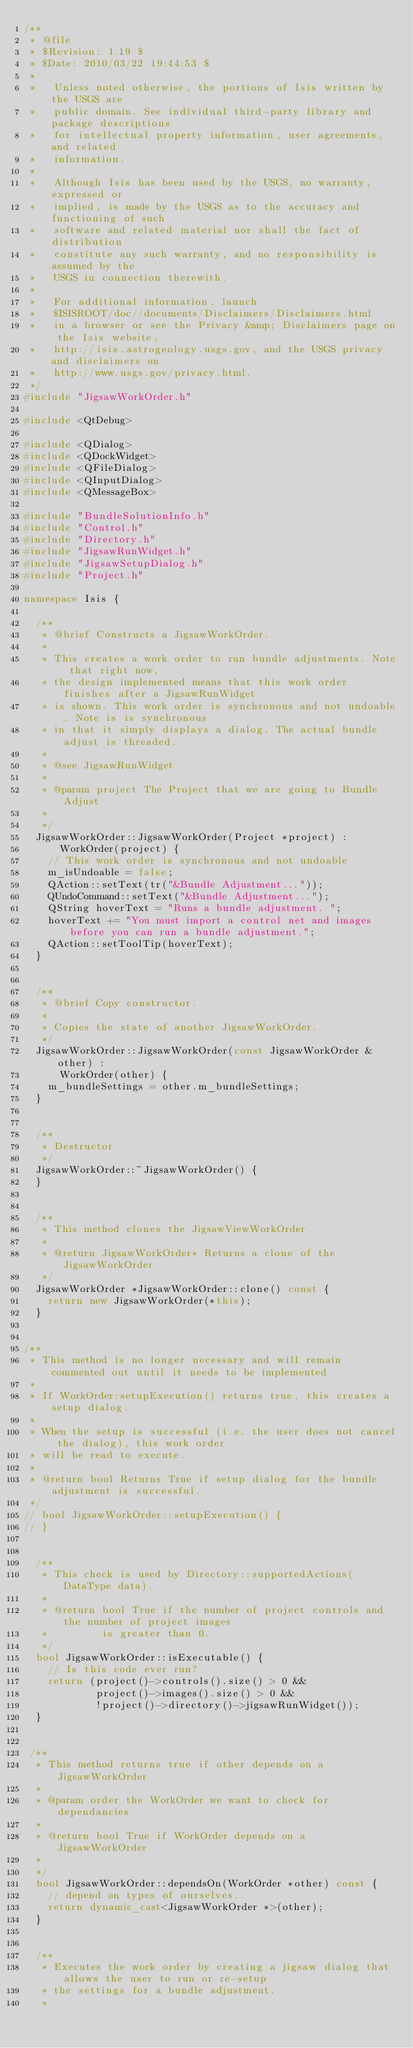<code> <loc_0><loc_0><loc_500><loc_500><_C++_>/**
 * @file
 * $Revision: 1.19 $
 * $Date: 2010/03/22 19:44:53 $
 *
 *   Unless noted otherwise, the portions of Isis written by the USGS are
 *   public domain. See individual third-party library and package descriptions
 *   for intellectual property information, user agreements, and related
 *   information.
 *
 *   Although Isis has been used by the USGS, no warranty, expressed or
 *   implied, is made by the USGS as to the accuracy and functioning of such
 *   software and related material nor shall the fact of distribution
 *   constitute any such warranty, and no responsibility is assumed by the
 *   USGS in connection therewith.
 *
 *   For additional information, launch
 *   $ISISROOT/doc//documents/Disclaimers/Disclaimers.html
 *   in a browser or see the Privacy &amp; Disclaimers page on the Isis website,
 *   http://isis.astrogeology.usgs.gov, and the USGS privacy and disclaimers on
 *   http://www.usgs.gov/privacy.html.
 */
#include "JigsawWorkOrder.h"

#include <QtDebug>

#include <QDialog>
#include <QDockWidget>
#include <QFileDialog>
#include <QInputDialog>
#include <QMessageBox>

#include "BundleSolutionInfo.h"
#include "Control.h"
#include "Directory.h"
#include "JigsawRunWidget.h"
#include "JigsawSetupDialog.h"
#include "Project.h"

namespace Isis {

  /**
   * @brief Constructs a JigsawWorkOrder.
   *
   * This creates a work order to run bundle adjustments. Note that right now,
   * the design implemented means that this work order finishes after a JigsawRunWidget
   * is shown. This work order is synchronous and not undoable. Note is is synchronous
   * in that it simply displays a dialog. The actual bundle adjust is threaded.
   *
   * @see JigsawRunWidget
   *
   * @param project The Project that we are going to Bundle Adjust
   *
   */
  JigsawWorkOrder::JigsawWorkOrder(Project *project) :
      WorkOrder(project) {
    // This work order is synchronous and not undoable
    m_isUndoable = false;
    QAction::setText(tr("&Bundle Adjustment..."));
    QUndoCommand::setText("&Bundle Adjustment...");
    QString hoverText = "Runs a bundle adjustment. ";
    hoverText += "You must import a control net and images before you can run a bundle adjustment.";
    QAction::setToolTip(hoverText);
  }


  /**
   * @brief Copy constructor.
   *
   * Copies the state of another JigsawWorkOrder.
   */
  JigsawWorkOrder::JigsawWorkOrder(const JigsawWorkOrder &other) :
      WorkOrder(other) {
    m_bundleSettings = other.m_bundleSettings;
  }


  /**
   * Destructor
   */
  JigsawWorkOrder::~JigsawWorkOrder() {
  }


  /**
   * This method clones the JigsawViewWorkOrder
   *
   * @return JigsawWorkOrder* Returns a clone of the JigsawWorkOrder
   */
  JigsawWorkOrder *JigsawWorkOrder::clone() const {
    return new JigsawWorkOrder(*this);
  }


/**
 * This method is no longer necessary and will remain commented out until it needs to be implemented 
 *  
 * If WorkOrder:setupExecution() returns true, this creates a setup dialog.   
 *    
 * When the setup is successful (i.e. the user does not cancel the dialog), this work order   
 * will be read to execute.   
 *    
 * @return bool Returns True if setup dialog for the bundle adjustment is successful.   
 */   
// bool JigsawWorkOrder::setupExecution() {    
// }


  /**
   * This check is used by Directory::supportedActions(DataType data).
   *
   * @return bool True if the number of project controls and the number of project images
   *         is greater than 0.
   */
  bool JigsawWorkOrder::isExecutable() {
    // Is this code ever run?
    return (project()->controls().size() > 0 && 
            project()->images().size() > 0 &&
            !project()->directory()->jigsawRunWidget());
  }


 /**
  * This method returns true if other depends on a JigsawWorkOrder
  *
  * @param order the WorkOrder we want to check for dependancies
  *
  * @return bool True if WorkOrder depends on a JigsawWorkOrder
  *
  */
  bool JigsawWorkOrder::dependsOn(WorkOrder *other) const {
    // depend on types of ourselves.
    return dynamic_cast<JigsawWorkOrder *>(other);
  }


  /**
   * Executes the work order by creating a jigsaw dialog that allows the user to run or re-setup
   * the settings for a bundle adjustment.
   *</code> 